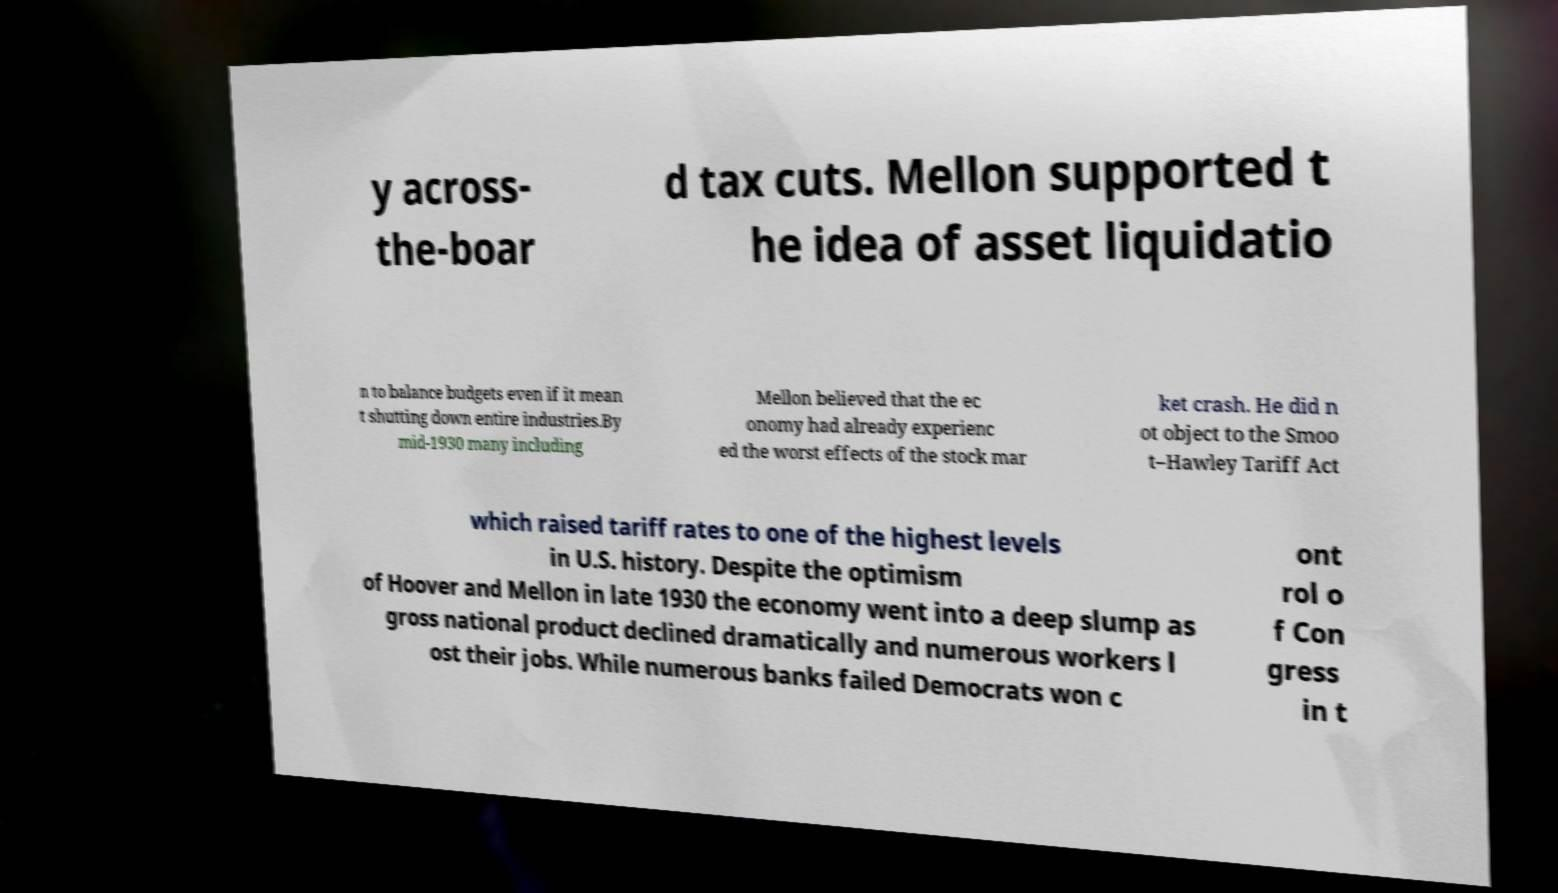Could you assist in decoding the text presented in this image and type it out clearly? y across- the-boar d tax cuts. Mellon supported t he idea of asset liquidatio n to balance budgets even if it mean t shutting down entire industries.By mid-1930 many including Mellon believed that the ec onomy had already experienc ed the worst effects of the stock mar ket crash. He did n ot object to the Smoo t–Hawley Tariff Act which raised tariff rates to one of the highest levels in U.S. history. Despite the optimism of Hoover and Mellon in late 1930 the economy went into a deep slump as gross national product declined dramatically and numerous workers l ost their jobs. While numerous banks failed Democrats won c ont rol o f Con gress in t 